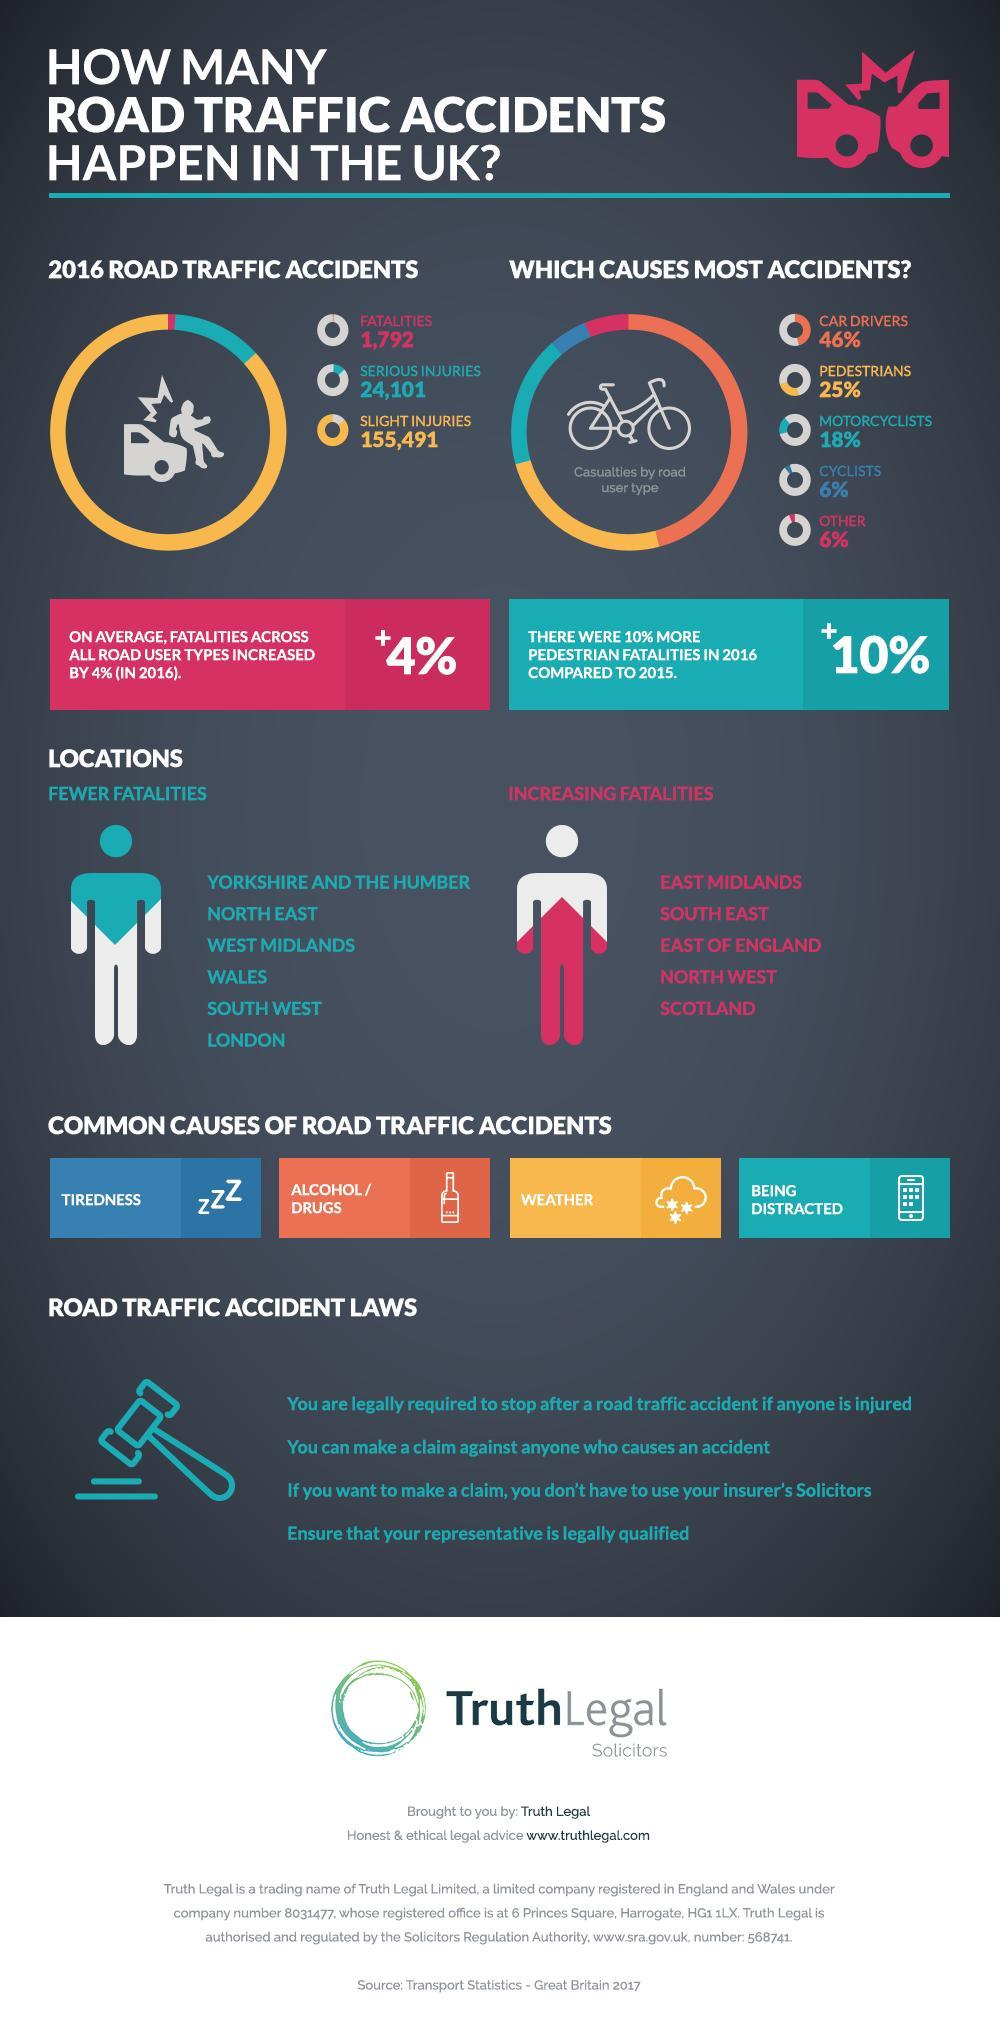How much of the accidents are caused by car drivers?
Answer the question with a short phrase. 46% What increased by 10% in 2016? Pedestrian Fatalities What is the second common cause for road accidents? Alcohol / Drugs How many fatalities were reported in the year 2016 due to road accidents? 1,792 What was the average increase in percentage of fatalities in road accidents? 4% What percentage of road accidents were caused by motorcyclists? 18% 1/4th of the road accidents were caused by whom? pedestrians Which is higher in number - fatalities, serious injuries or slight injuries? slight injuries Which location saw fewer fatalities - North West, North East or South East? North East Who are responsible for the highest percentage of accidents? Car drivers 